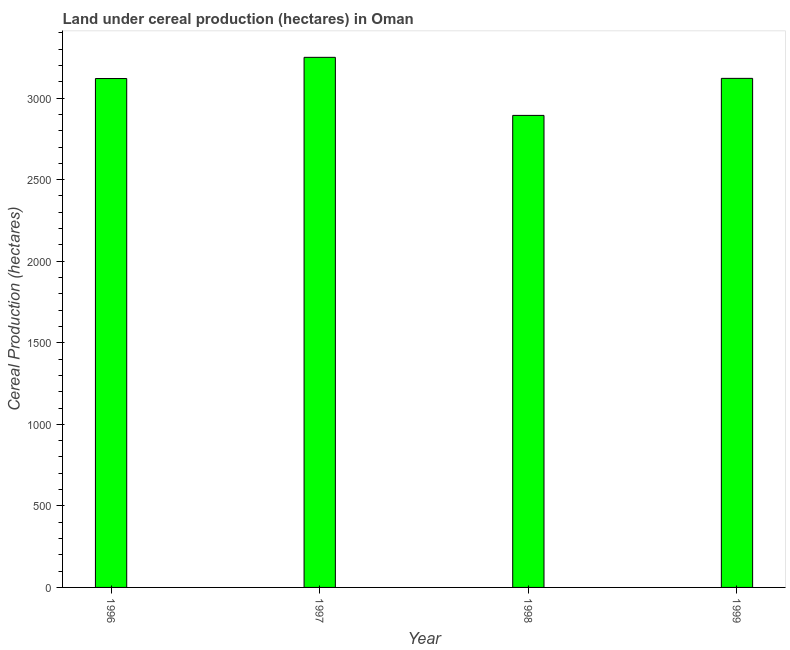Does the graph contain any zero values?
Give a very brief answer. No. What is the title of the graph?
Offer a very short reply. Land under cereal production (hectares) in Oman. What is the label or title of the X-axis?
Ensure brevity in your answer.  Year. What is the label or title of the Y-axis?
Ensure brevity in your answer.  Cereal Production (hectares). What is the land under cereal production in 1998?
Ensure brevity in your answer.  2894. Across all years, what is the maximum land under cereal production?
Your answer should be very brief. 3250. Across all years, what is the minimum land under cereal production?
Keep it short and to the point. 2894. In which year was the land under cereal production maximum?
Provide a succinct answer. 1997. In which year was the land under cereal production minimum?
Offer a terse response. 1998. What is the sum of the land under cereal production?
Provide a succinct answer. 1.24e+04. What is the difference between the land under cereal production in 1998 and 1999?
Provide a short and direct response. -227. What is the average land under cereal production per year?
Offer a terse response. 3096.25. What is the median land under cereal production?
Your response must be concise. 3120.5. What is the ratio of the land under cereal production in 1998 to that in 1999?
Your answer should be compact. 0.93. What is the difference between the highest and the second highest land under cereal production?
Provide a short and direct response. 129. Is the sum of the land under cereal production in 1996 and 1997 greater than the maximum land under cereal production across all years?
Provide a succinct answer. Yes. What is the difference between the highest and the lowest land under cereal production?
Your answer should be very brief. 356. In how many years, is the land under cereal production greater than the average land under cereal production taken over all years?
Provide a short and direct response. 3. How many bars are there?
Your answer should be very brief. 4. How many years are there in the graph?
Your answer should be very brief. 4. What is the difference between two consecutive major ticks on the Y-axis?
Your answer should be very brief. 500. What is the Cereal Production (hectares) in 1996?
Give a very brief answer. 3120. What is the Cereal Production (hectares) of 1997?
Keep it short and to the point. 3250. What is the Cereal Production (hectares) in 1998?
Keep it short and to the point. 2894. What is the Cereal Production (hectares) of 1999?
Your response must be concise. 3121. What is the difference between the Cereal Production (hectares) in 1996 and 1997?
Make the answer very short. -130. What is the difference between the Cereal Production (hectares) in 1996 and 1998?
Provide a short and direct response. 226. What is the difference between the Cereal Production (hectares) in 1997 and 1998?
Make the answer very short. 356. What is the difference between the Cereal Production (hectares) in 1997 and 1999?
Give a very brief answer. 129. What is the difference between the Cereal Production (hectares) in 1998 and 1999?
Provide a short and direct response. -227. What is the ratio of the Cereal Production (hectares) in 1996 to that in 1997?
Offer a terse response. 0.96. What is the ratio of the Cereal Production (hectares) in 1996 to that in 1998?
Offer a terse response. 1.08. What is the ratio of the Cereal Production (hectares) in 1997 to that in 1998?
Offer a very short reply. 1.12. What is the ratio of the Cereal Production (hectares) in 1997 to that in 1999?
Give a very brief answer. 1.04. What is the ratio of the Cereal Production (hectares) in 1998 to that in 1999?
Give a very brief answer. 0.93. 